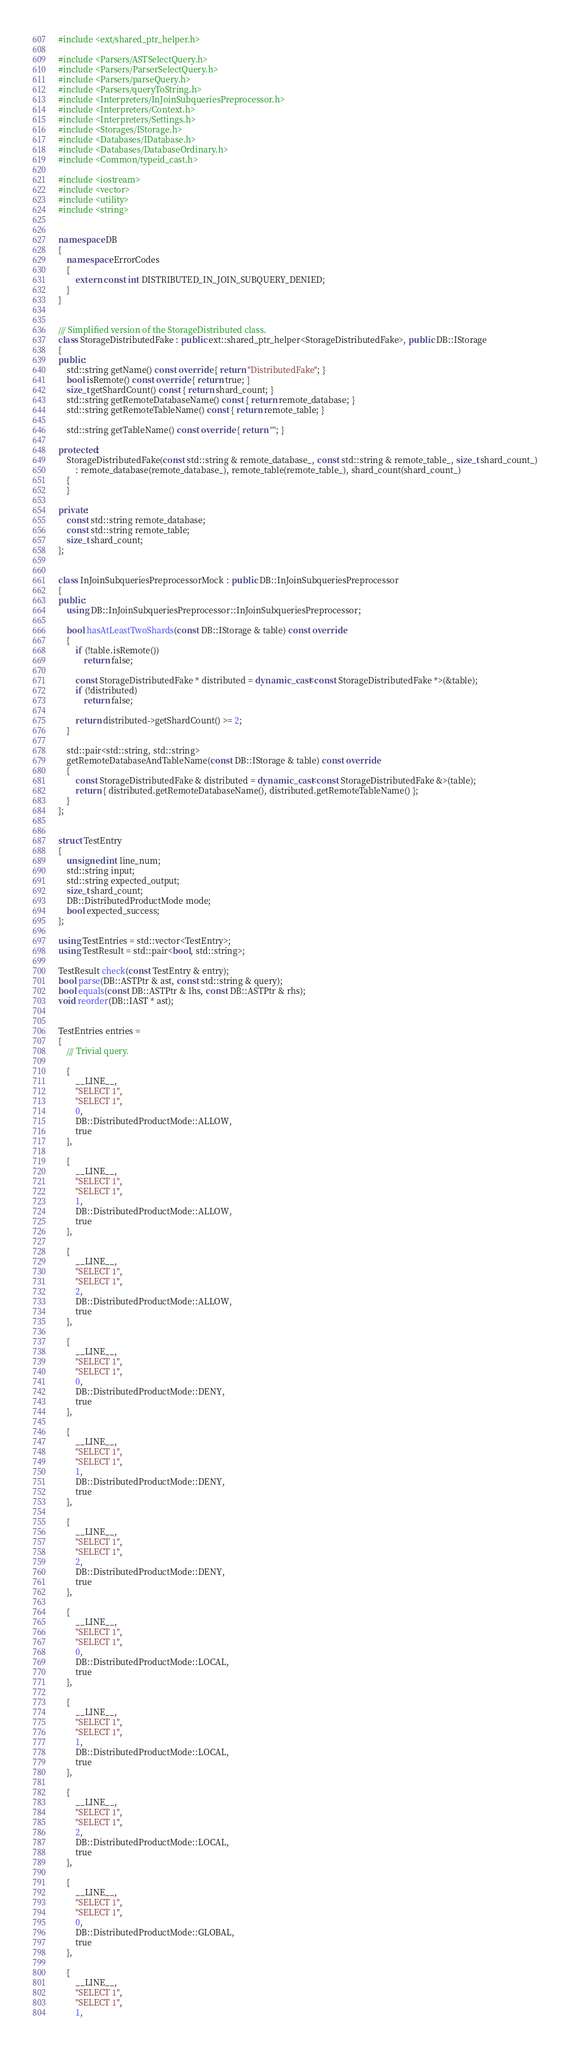<code> <loc_0><loc_0><loc_500><loc_500><_C++_>#include <ext/shared_ptr_helper.h>

#include <Parsers/ASTSelectQuery.h>
#include <Parsers/ParserSelectQuery.h>
#include <Parsers/parseQuery.h>
#include <Parsers/queryToString.h>
#include <Interpreters/InJoinSubqueriesPreprocessor.h>
#include <Interpreters/Context.h>
#include <Interpreters/Settings.h>
#include <Storages/IStorage.h>
#include <Databases/IDatabase.h>
#include <Databases/DatabaseOrdinary.h>
#include <Common/typeid_cast.h>

#include <iostream>
#include <vector>
#include <utility>
#include <string>


namespace DB
{
    namespace ErrorCodes
    {
        extern const int DISTRIBUTED_IN_JOIN_SUBQUERY_DENIED;
    }
}


/// Simplified version of the StorageDistributed class.
class StorageDistributedFake : public ext::shared_ptr_helper<StorageDistributedFake>, public DB::IStorage
{
public:
    std::string getName() const override { return "DistributedFake"; }
    bool isRemote() const override { return true; }
    size_t getShardCount() const { return shard_count; }
    std::string getRemoteDatabaseName() const { return remote_database; }
    std::string getRemoteTableName() const { return remote_table; }

    std::string getTableName() const override { return ""; }

protected:
    StorageDistributedFake(const std::string & remote_database_, const std::string & remote_table_, size_t shard_count_)
        : remote_database(remote_database_), remote_table(remote_table_), shard_count(shard_count_)
    {
    }

private:
    const std::string remote_database;
    const std::string remote_table;
    size_t shard_count;
};


class InJoinSubqueriesPreprocessorMock : public DB::InJoinSubqueriesPreprocessor
{
public:
    using DB::InJoinSubqueriesPreprocessor::InJoinSubqueriesPreprocessor;

    bool hasAtLeastTwoShards(const DB::IStorage & table) const override
    {
        if (!table.isRemote())
            return false;

        const StorageDistributedFake * distributed = dynamic_cast<const StorageDistributedFake *>(&table);
        if (!distributed)
            return false;

        return distributed->getShardCount() >= 2;
    }

    std::pair<std::string, std::string>
    getRemoteDatabaseAndTableName(const DB::IStorage & table) const override
    {
        const StorageDistributedFake & distributed = dynamic_cast<const StorageDistributedFake &>(table);
        return { distributed.getRemoteDatabaseName(), distributed.getRemoteTableName() };
    }
};


struct TestEntry
{
    unsigned int line_num;
    std::string input;
    std::string expected_output;
    size_t shard_count;
    DB::DistributedProductMode mode;
    bool expected_success;
};

using TestEntries = std::vector<TestEntry>;
using TestResult = std::pair<bool, std::string>;

TestResult check(const TestEntry & entry);
bool parse(DB::ASTPtr & ast, const std::string & query);
bool equals(const DB::ASTPtr & lhs, const DB::ASTPtr & rhs);
void reorder(DB::IAST * ast);


TestEntries entries =
{
    /// Trivial query.

    {
        __LINE__,
        "SELECT 1",
        "SELECT 1",
        0,
        DB::DistributedProductMode::ALLOW,
        true
    },

    {
        __LINE__,
        "SELECT 1",
        "SELECT 1",
        1,
        DB::DistributedProductMode::ALLOW,
        true
    },

    {
        __LINE__,
        "SELECT 1",
        "SELECT 1",
        2,
        DB::DistributedProductMode::ALLOW,
        true
    },

    {
        __LINE__,
        "SELECT 1",
        "SELECT 1",
        0,
        DB::DistributedProductMode::DENY,
        true
    },

    {
        __LINE__,
        "SELECT 1",
        "SELECT 1",
        1,
        DB::DistributedProductMode::DENY,
        true
    },

    {
        __LINE__,
        "SELECT 1",
        "SELECT 1",
        2,
        DB::DistributedProductMode::DENY,
        true
    },

    {
        __LINE__,
        "SELECT 1",
        "SELECT 1",
        0,
        DB::DistributedProductMode::LOCAL,
        true
    },

    {
        __LINE__,
        "SELECT 1",
        "SELECT 1",
        1,
        DB::DistributedProductMode::LOCAL,
        true
    },

    {
        __LINE__,
        "SELECT 1",
        "SELECT 1",
        2,
        DB::DistributedProductMode::LOCAL,
        true
    },

    {
        __LINE__,
        "SELECT 1",
        "SELECT 1",
        0,
        DB::DistributedProductMode::GLOBAL,
        true
    },

    {
        __LINE__,
        "SELECT 1",
        "SELECT 1",
        1,</code> 